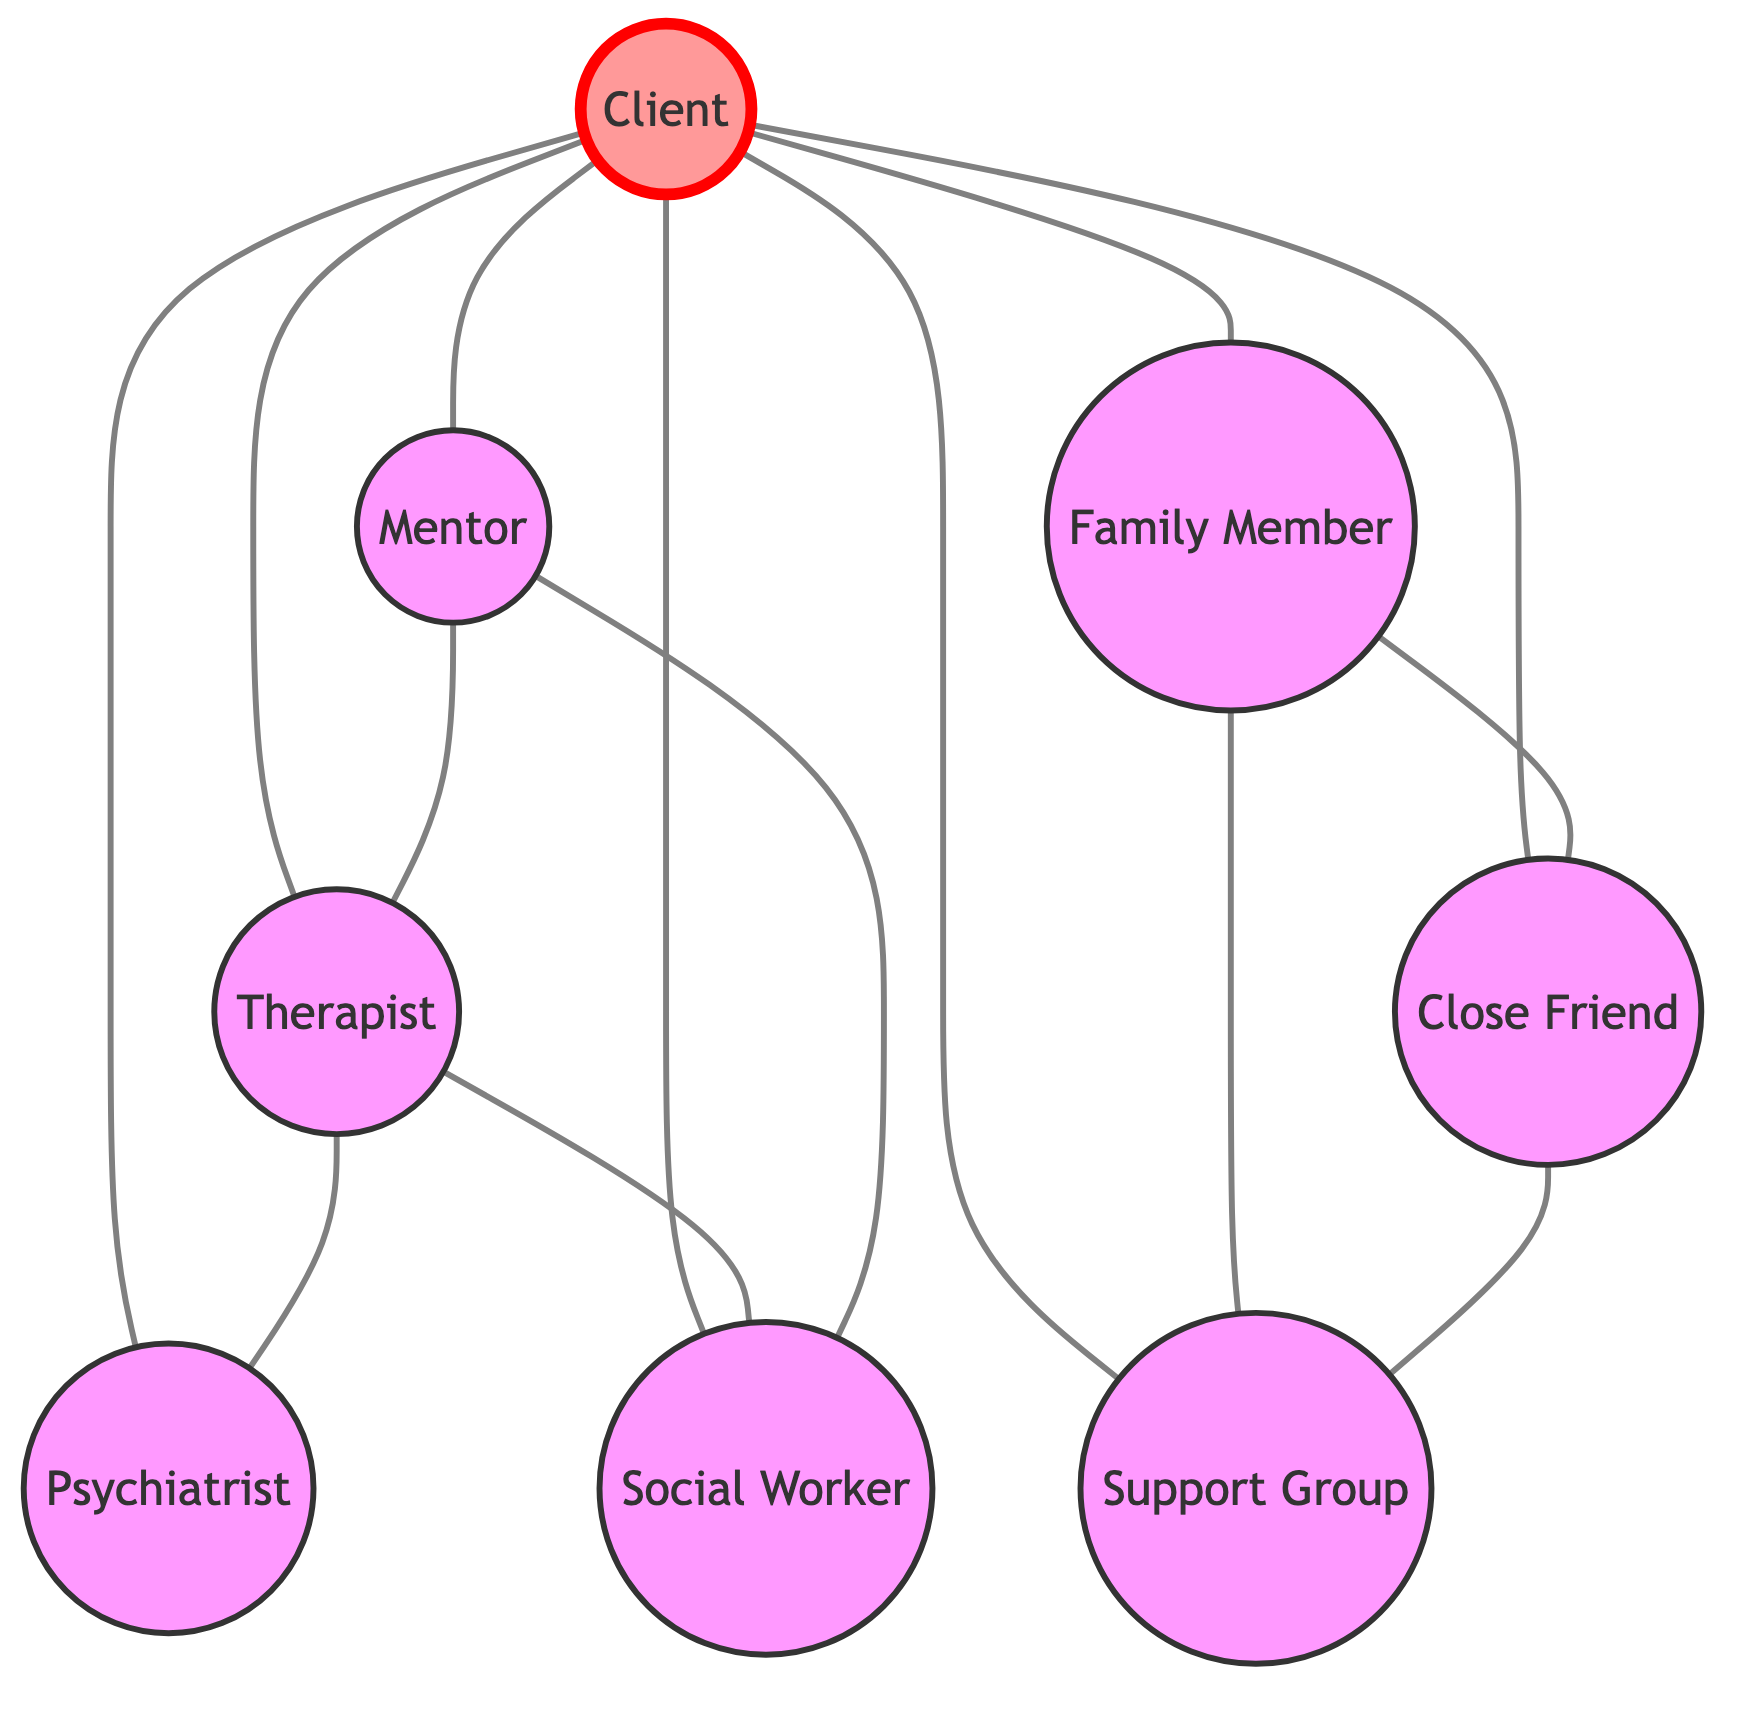What node is directly connected to the client? The client is connected to several nodes directly in the diagram. These nodes include the therapist, family member, close friend, support group, psychiatrist, mentor, and social worker.
Answer: therapist, family member, close friend, support group, psychiatrist, mentor, social worker How many total nodes are there in the diagram? The diagram consists of 8 different nodes representing the various roles in the client support network. Counting each unique node gives us a total of 8.
Answer: 8 What is the relationship between the therapist and the psychiatrist? The therapist and psychiatrist are directly connected in the diagram, indicating a supportive relationship between these two roles in the context of trauma recovery.
Answer: directly connected Which node has the most connections in the diagram? The client node is the most central in the diagram with connections to multiple other nodes—specifically, it connects to seven nodes.
Answer: client What is the only node connected to both the therapist and the social worker? The mentor node has connections to both the therapist and the social worker, highlighting its role as a bridge between these two important figures.
Answer: mentor How many connections does the support group have? The support group is connected to three different nodes in the diagram: the client, family member, and close friend. Each represents a direct relationship showcasing the different forms of support available.
Answer: 3 Which nodes are connected through a family member? The family member node connects to the close friend and the support group, indicating whom the family member is likely to influence or receive support from.
Answer: close friend, support group How many total edges are there in the diagram? The diagram features 13 edges, which represent the connections between the various nodes, showing how individuals interact within the support network.
Answer: 13 